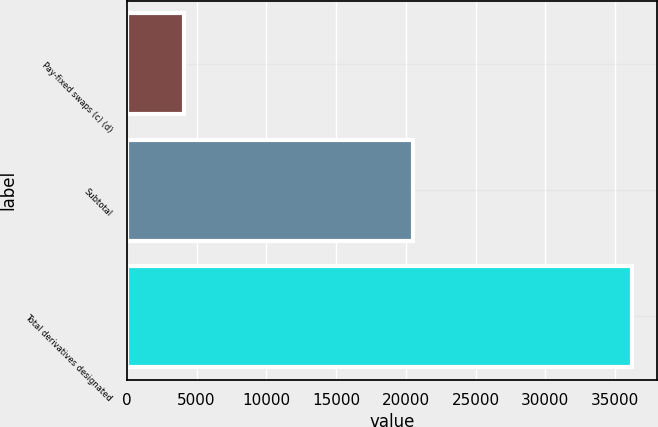<chart> <loc_0><loc_0><loc_500><loc_500><bar_chart><fcel>Pay-fixed swaps (c) (d)<fcel>Subtotal<fcel>Total derivatives designated<nl><fcel>4076<fcel>20522<fcel>36197<nl></chart> 